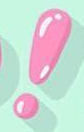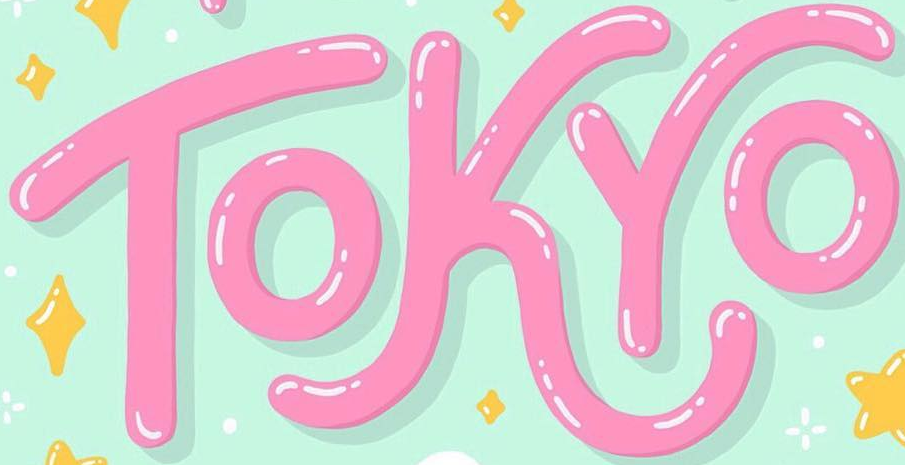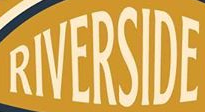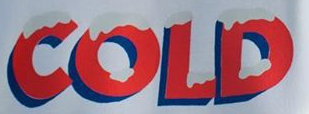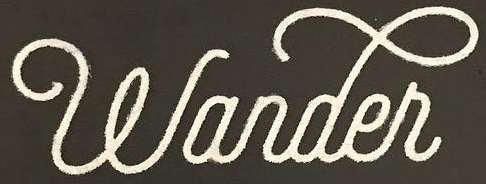What text appears in these images from left to right, separated by a semicolon? !; TOKYO; RIVERSIDE; COLD; wander 